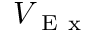<formula> <loc_0><loc_0><loc_500><loc_500>V _ { E x }</formula> 